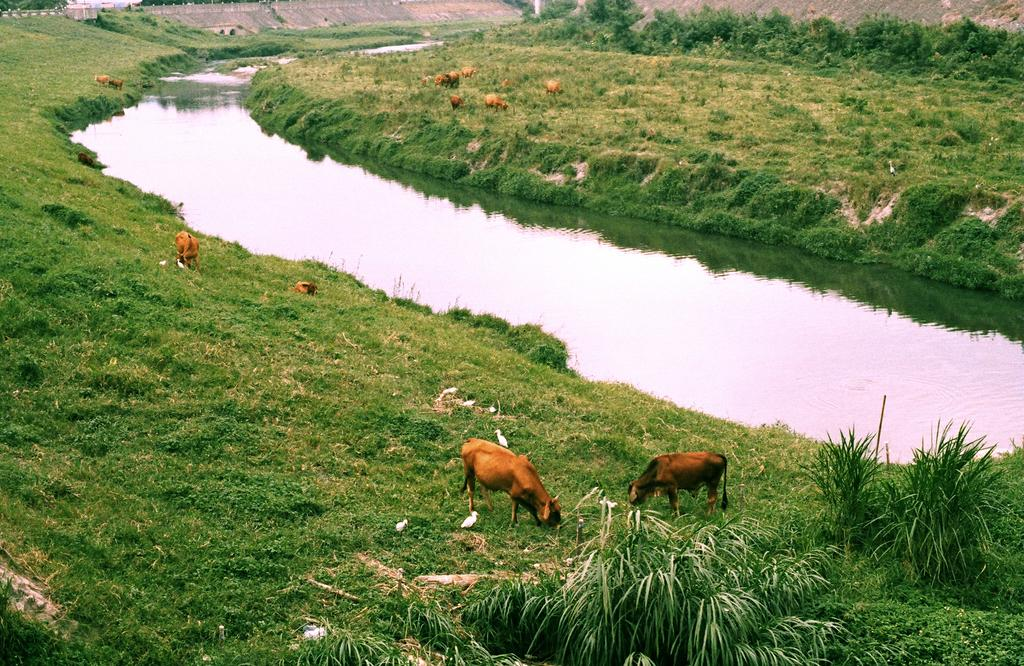What are the animals in the image doing? The animals are grazing the grass in the image. What type of vegetation can be seen in the image? There are plants and grass in the image. What can be seen in the background of the image? There is a lake and a dam in the background of the image. How many clover leaves can be seen in the image? There is no mention of clover in the image, so it is impossible to determine the number of clover leaves present. 